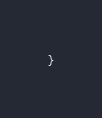<code> <loc_0><loc_0><loc_500><loc_500><_Awk_>}
</code> 